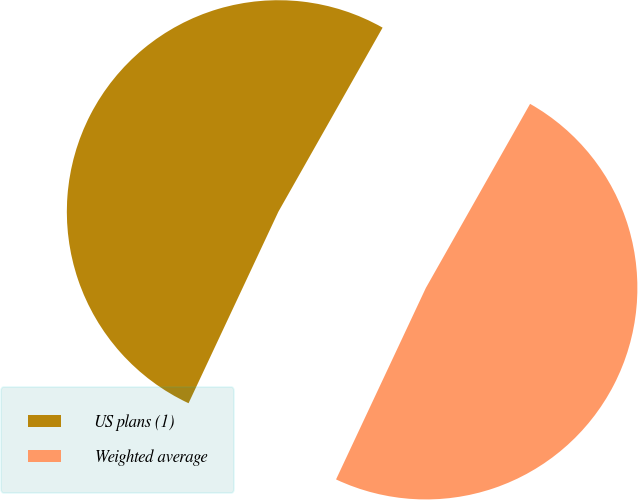<chart> <loc_0><loc_0><loc_500><loc_500><pie_chart><fcel>US plans (1)<fcel>Weighted average<nl><fcel>51.22%<fcel>48.78%<nl></chart> 